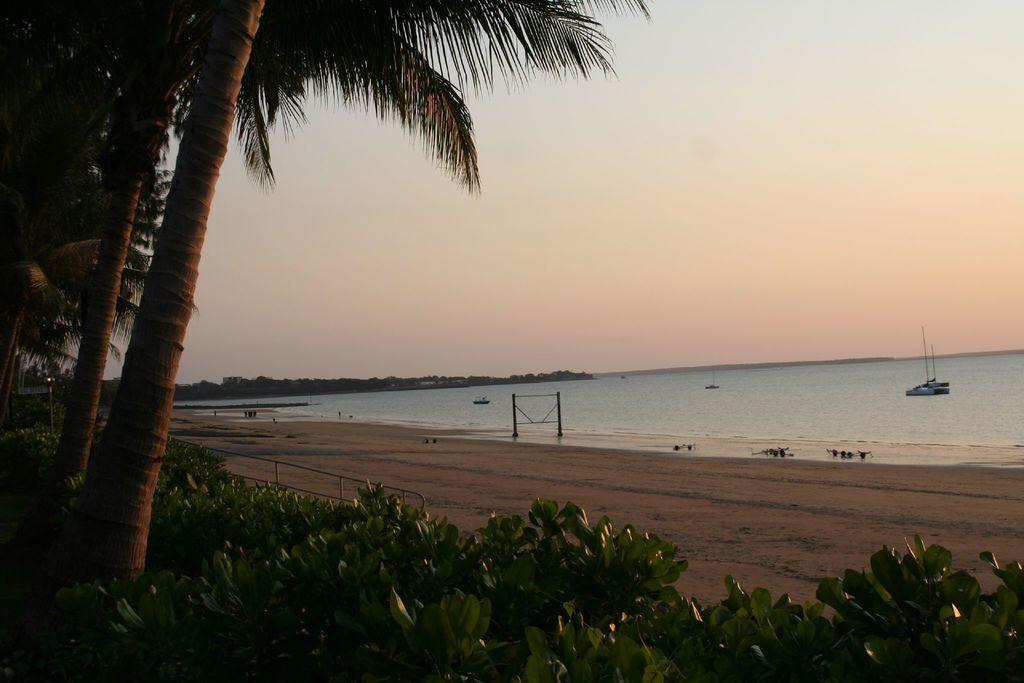What is on the water in the image? There are boats on the water in the image. What type of vegetation can be seen in the image? There are trees and plants in the image. What structures are present in the image? There are poles in the image. What else can be seen in the image besides the boats, trees, plants, and poles? There are other unspecified objects in the image. What is visible in the background of the image? The sky is visible in the background of the image. Can you see the smile on the rock in the image? There is no rock or smile present in the image. What type of cable is connecting the boats in the image? There is no cable connecting the boats in the image; they are on the water separately. 